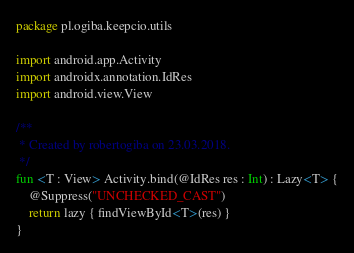Convert code to text. <code><loc_0><loc_0><loc_500><loc_500><_Kotlin_>package pl.ogiba.keepcio.utils

import android.app.Activity
import androidx.annotation.IdRes
import android.view.View

/**
 * Created by robertogiba on 23.03.2018.
 */
fun <T : View> Activity.bind(@IdRes res : Int) : Lazy<T> {
    @Suppress("UNCHECKED_CAST")
    return lazy { findViewById<T>(res) }
}</code> 